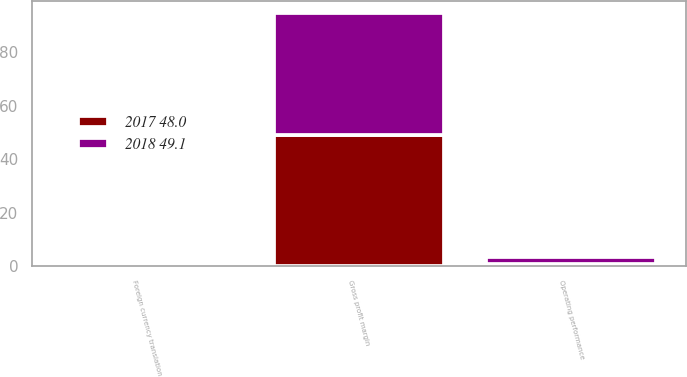<chart> <loc_0><loc_0><loc_500><loc_500><stacked_bar_chart><ecel><fcel>Operating performance<fcel>Foreign currency translation<fcel>Gross profit margin<nl><fcel>2018 49.1<fcel>2.8<fcel>0.4<fcel>45.4<nl><fcel>2017 48.0<fcel>0.7<fcel>0.4<fcel>49.1<nl></chart> 